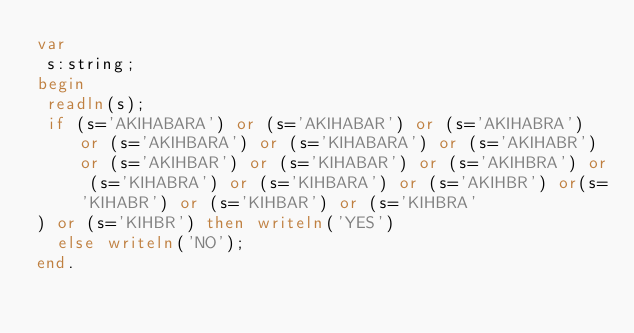Convert code to text. <code><loc_0><loc_0><loc_500><loc_500><_Pascal_>var
 s:string;
begin
 readln(s);
 if (s='AKIHABARA') or (s='AKIHABAR') or (s='AKIHABRA') or (s='AKIHBARA') or (s='KIHABARA') or (s='AKIHABR') or (s='AKIHBAR') or (s='KIHABAR') or (s='AKIHBRA') or (s='KIHABRA') or (s='KIHBARA') or (s='AKIHBR') or(s='KIHABR') or (s='KIHBAR') or (s='KIHBRA'
) or (s='KIHBR') then writeln('YES')
  else writeln('NO');
end.
</code> 